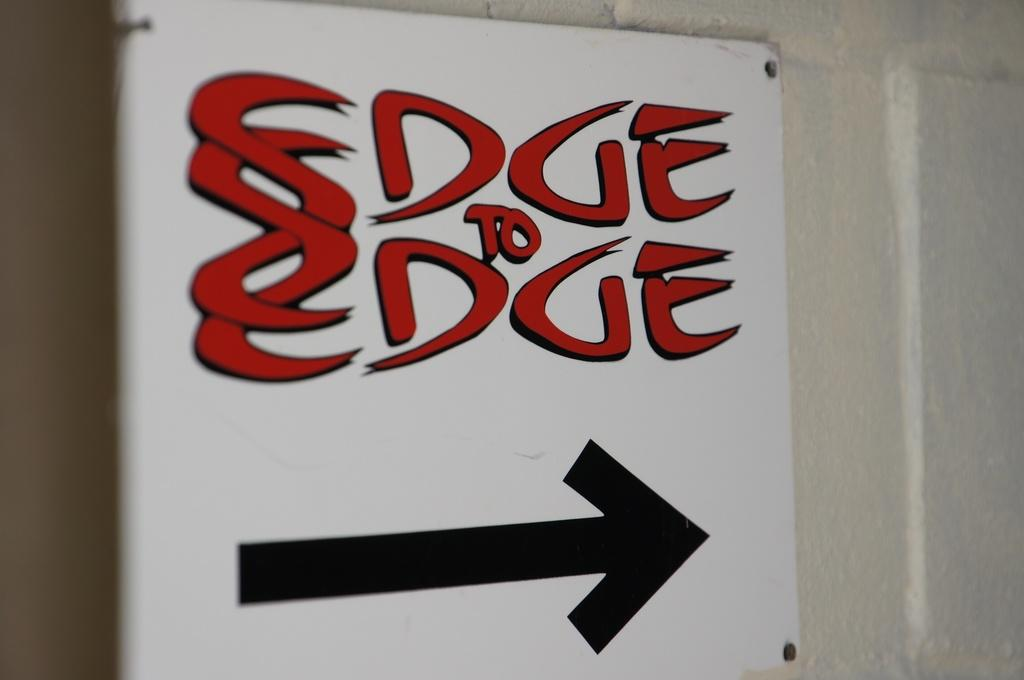<image>
Provide a brief description of the given image. A sign that says Edge to Edge written in Red with a black arrow pointing to the right under. 